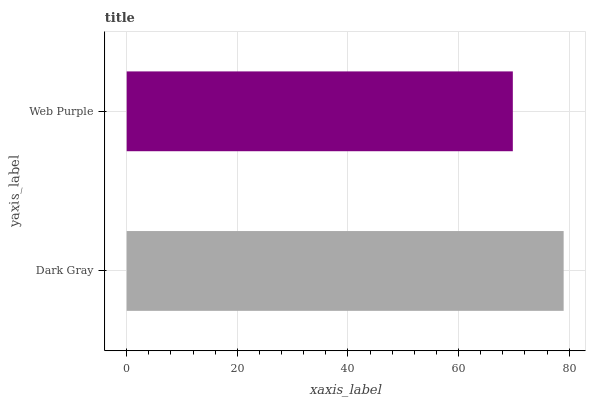Is Web Purple the minimum?
Answer yes or no. Yes. Is Dark Gray the maximum?
Answer yes or no. Yes. Is Web Purple the maximum?
Answer yes or no. No. Is Dark Gray greater than Web Purple?
Answer yes or no. Yes. Is Web Purple less than Dark Gray?
Answer yes or no. Yes. Is Web Purple greater than Dark Gray?
Answer yes or no. No. Is Dark Gray less than Web Purple?
Answer yes or no. No. Is Dark Gray the high median?
Answer yes or no. Yes. Is Web Purple the low median?
Answer yes or no. Yes. Is Web Purple the high median?
Answer yes or no. No. Is Dark Gray the low median?
Answer yes or no. No. 